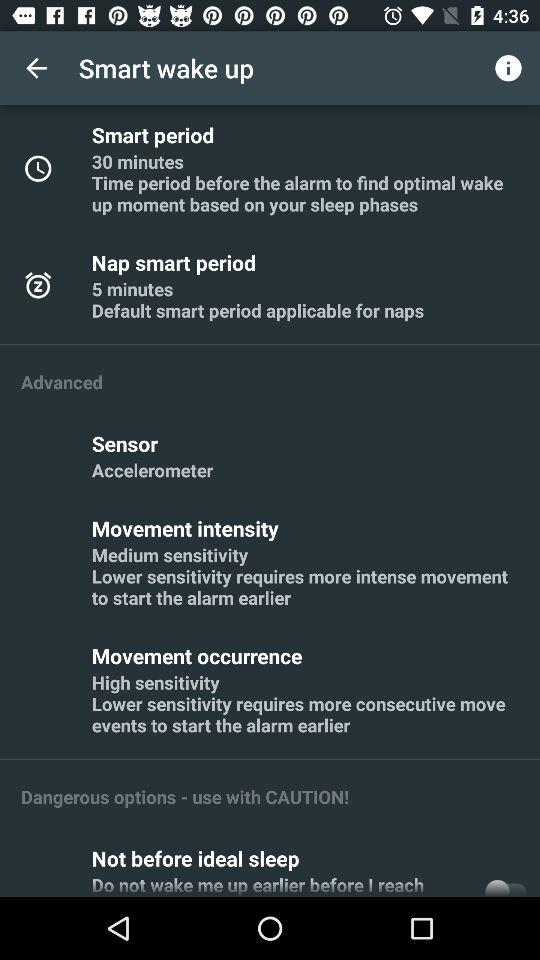What is the time duration of "Smart period"? The time duration is 30 minutes. 